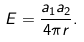<formula> <loc_0><loc_0><loc_500><loc_500>E = { \frac { a _ { 1 } a _ { 2 } } { 4 \pi r } } .</formula> 